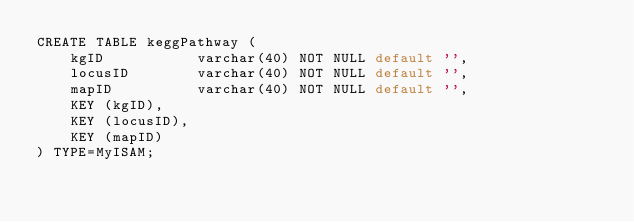Convert code to text. <code><loc_0><loc_0><loc_500><loc_500><_SQL_>CREATE TABLE keggPathway (
    kgID           varchar(40) NOT NULL default '',
    locusID        varchar(40) NOT NULL default '',
    mapID          varchar(40) NOT NULL default '',
    KEY (kgID),
    KEY (locusID),
    KEY (mapID)
) TYPE=MyISAM;
</code> 